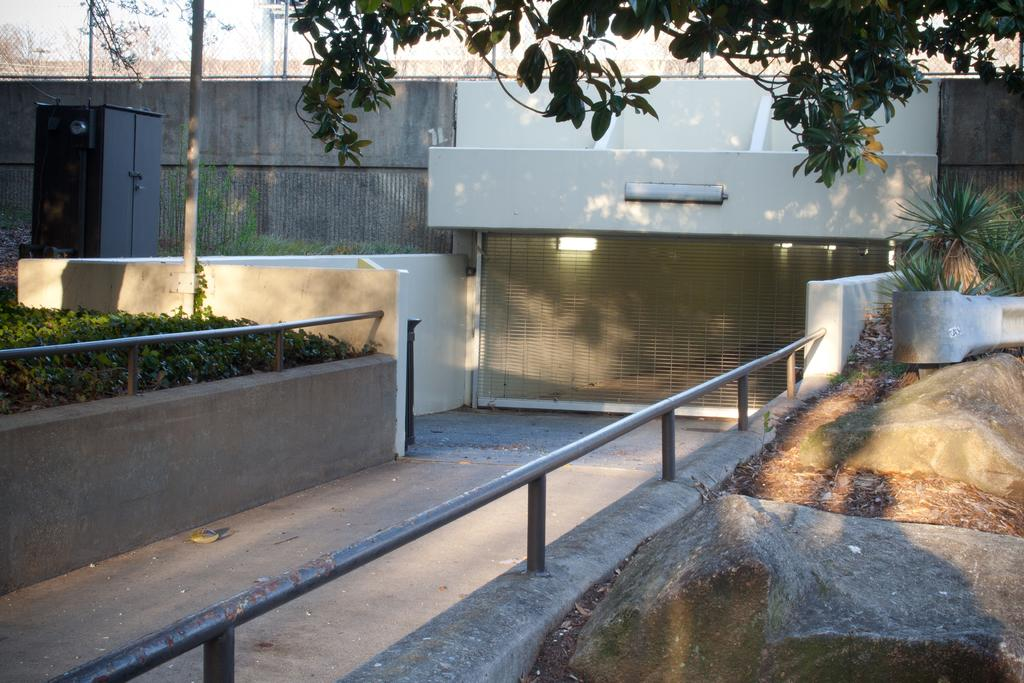What type of structure can be seen in the image? There is fencing in the image. What type of vegetation is present in the image? There are plants and trees in the image. What else can be seen in the image besides fencing and vegetation? There are poles in the image. What type of spark can be seen coming from the airplane in the image? There is no airplane present in the image, so there is no spark to observe. What type of fork is being used to eat the plants in the image? There are no people or forks present in the image, and the plants are not being eaten. 